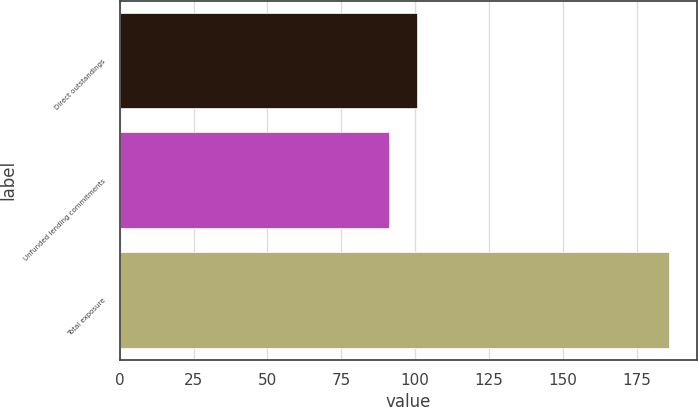<chart> <loc_0><loc_0><loc_500><loc_500><bar_chart><fcel>Direct outstandings<fcel>Unfunded lending commitments<fcel>Total exposure<nl><fcel>100.5<fcel>91<fcel>186<nl></chart> 